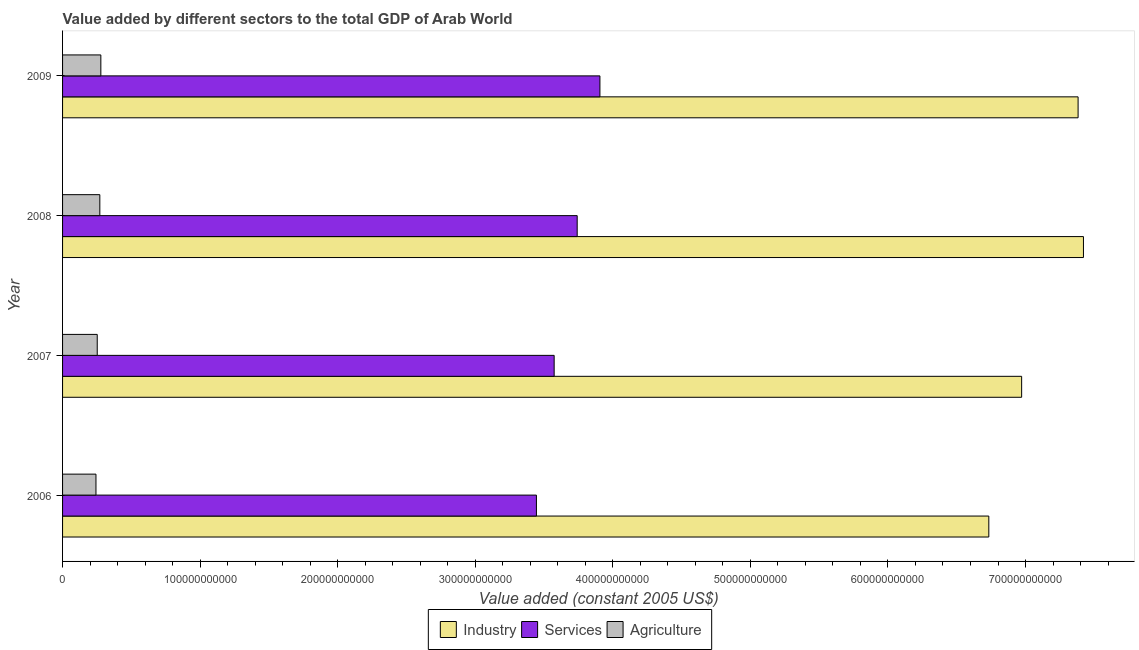Are the number of bars per tick equal to the number of legend labels?
Offer a very short reply. Yes. Are the number of bars on each tick of the Y-axis equal?
Give a very brief answer. Yes. How many bars are there on the 3rd tick from the top?
Provide a succinct answer. 3. In how many cases, is the number of bars for a given year not equal to the number of legend labels?
Provide a short and direct response. 0. What is the value added by agricultural sector in 2008?
Your answer should be very brief. 2.71e+1. Across all years, what is the maximum value added by agricultural sector?
Provide a succinct answer. 2.78e+1. Across all years, what is the minimum value added by industrial sector?
Your answer should be compact. 6.73e+11. In which year was the value added by agricultural sector maximum?
Provide a succinct answer. 2009. What is the total value added by industrial sector in the graph?
Provide a succinct answer. 2.85e+12. What is the difference between the value added by agricultural sector in 2006 and that in 2007?
Keep it short and to the point. -9.24e+08. What is the difference between the value added by industrial sector in 2009 and the value added by agricultural sector in 2008?
Make the answer very short. 7.11e+11. What is the average value added by agricultural sector per year?
Offer a very short reply. 2.61e+1. In the year 2006, what is the difference between the value added by industrial sector and value added by agricultural sector?
Offer a very short reply. 6.49e+11. In how many years, is the value added by services greater than 660000000000 US$?
Your answer should be very brief. 0. What is the ratio of the value added by industrial sector in 2006 to that in 2009?
Make the answer very short. 0.91. Is the value added by industrial sector in 2007 less than that in 2008?
Your answer should be compact. Yes. Is the difference between the value added by services in 2008 and 2009 greater than the difference between the value added by industrial sector in 2008 and 2009?
Make the answer very short. No. What is the difference between the highest and the second highest value added by agricultural sector?
Make the answer very short. 7.33e+08. What is the difference between the highest and the lowest value added by industrial sector?
Your answer should be very brief. 6.88e+1. Is the sum of the value added by industrial sector in 2008 and 2009 greater than the maximum value added by agricultural sector across all years?
Keep it short and to the point. Yes. What does the 3rd bar from the top in 2007 represents?
Your answer should be compact. Industry. What does the 2nd bar from the bottom in 2007 represents?
Offer a very short reply. Services. How many bars are there?
Your response must be concise. 12. How many years are there in the graph?
Your answer should be compact. 4. What is the difference between two consecutive major ticks on the X-axis?
Give a very brief answer. 1.00e+11. What is the title of the graph?
Your answer should be compact. Value added by different sectors to the total GDP of Arab World. Does "Textiles and clothing" appear as one of the legend labels in the graph?
Ensure brevity in your answer.  No. What is the label or title of the X-axis?
Provide a succinct answer. Value added (constant 2005 US$). What is the label or title of the Y-axis?
Give a very brief answer. Year. What is the Value added (constant 2005 US$) in Industry in 2006?
Your answer should be very brief. 6.73e+11. What is the Value added (constant 2005 US$) in Services in 2006?
Your answer should be very brief. 3.44e+11. What is the Value added (constant 2005 US$) of Agriculture in 2006?
Provide a succinct answer. 2.43e+1. What is the Value added (constant 2005 US$) in Industry in 2007?
Your answer should be very brief. 6.97e+11. What is the Value added (constant 2005 US$) in Services in 2007?
Your answer should be compact. 3.57e+11. What is the Value added (constant 2005 US$) in Agriculture in 2007?
Offer a terse response. 2.52e+1. What is the Value added (constant 2005 US$) of Industry in 2008?
Your answer should be very brief. 7.42e+11. What is the Value added (constant 2005 US$) in Services in 2008?
Ensure brevity in your answer.  3.74e+11. What is the Value added (constant 2005 US$) of Agriculture in 2008?
Give a very brief answer. 2.71e+1. What is the Value added (constant 2005 US$) of Industry in 2009?
Give a very brief answer. 7.38e+11. What is the Value added (constant 2005 US$) in Services in 2009?
Offer a very short reply. 3.91e+11. What is the Value added (constant 2005 US$) in Agriculture in 2009?
Your answer should be compact. 2.78e+1. Across all years, what is the maximum Value added (constant 2005 US$) of Industry?
Provide a short and direct response. 7.42e+11. Across all years, what is the maximum Value added (constant 2005 US$) of Services?
Offer a terse response. 3.91e+11. Across all years, what is the maximum Value added (constant 2005 US$) in Agriculture?
Your answer should be very brief. 2.78e+1. Across all years, what is the minimum Value added (constant 2005 US$) of Industry?
Keep it short and to the point. 6.73e+11. Across all years, what is the minimum Value added (constant 2005 US$) of Services?
Offer a terse response. 3.44e+11. Across all years, what is the minimum Value added (constant 2005 US$) of Agriculture?
Give a very brief answer. 2.43e+1. What is the total Value added (constant 2005 US$) in Industry in the graph?
Provide a succinct answer. 2.85e+12. What is the total Value added (constant 2005 US$) of Services in the graph?
Provide a succinct answer. 1.47e+12. What is the total Value added (constant 2005 US$) in Agriculture in the graph?
Offer a terse response. 1.04e+11. What is the difference between the Value added (constant 2005 US$) of Industry in 2006 and that in 2007?
Make the answer very short. -2.39e+1. What is the difference between the Value added (constant 2005 US$) in Services in 2006 and that in 2007?
Offer a terse response. -1.29e+1. What is the difference between the Value added (constant 2005 US$) of Agriculture in 2006 and that in 2007?
Provide a succinct answer. -9.24e+08. What is the difference between the Value added (constant 2005 US$) in Industry in 2006 and that in 2008?
Offer a very short reply. -6.88e+1. What is the difference between the Value added (constant 2005 US$) of Services in 2006 and that in 2008?
Give a very brief answer. -2.96e+1. What is the difference between the Value added (constant 2005 US$) of Agriculture in 2006 and that in 2008?
Your answer should be compact. -2.81e+09. What is the difference between the Value added (constant 2005 US$) of Industry in 2006 and that in 2009?
Your answer should be very brief. -6.49e+1. What is the difference between the Value added (constant 2005 US$) of Services in 2006 and that in 2009?
Provide a short and direct response. -4.62e+1. What is the difference between the Value added (constant 2005 US$) in Agriculture in 2006 and that in 2009?
Make the answer very short. -3.54e+09. What is the difference between the Value added (constant 2005 US$) in Industry in 2007 and that in 2008?
Offer a very short reply. -4.49e+1. What is the difference between the Value added (constant 2005 US$) of Services in 2007 and that in 2008?
Give a very brief answer. -1.67e+1. What is the difference between the Value added (constant 2005 US$) of Agriculture in 2007 and that in 2008?
Give a very brief answer. -1.89e+09. What is the difference between the Value added (constant 2005 US$) in Industry in 2007 and that in 2009?
Offer a terse response. -4.10e+1. What is the difference between the Value added (constant 2005 US$) of Services in 2007 and that in 2009?
Offer a terse response. -3.33e+1. What is the difference between the Value added (constant 2005 US$) of Agriculture in 2007 and that in 2009?
Make the answer very short. -2.62e+09. What is the difference between the Value added (constant 2005 US$) in Industry in 2008 and that in 2009?
Your response must be concise. 3.89e+09. What is the difference between the Value added (constant 2005 US$) of Services in 2008 and that in 2009?
Your response must be concise. -1.65e+1. What is the difference between the Value added (constant 2005 US$) of Agriculture in 2008 and that in 2009?
Your answer should be compact. -7.33e+08. What is the difference between the Value added (constant 2005 US$) of Industry in 2006 and the Value added (constant 2005 US$) of Services in 2007?
Ensure brevity in your answer.  3.16e+11. What is the difference between the Value added (constant 2005 US$) of Industry in 2006 and the Value added (constant 2005 US$) of Agriculture in 2007?
Offer a terse response. 6.48e+11. What is the difference between the Value added (constant 2005 US$) in Services in 2006 and the Value added (constant 2005 US$) in Agriculture in 2007?
Offer a terse response. 3.19e+11. What is the difference between the Value added (constant 2005 US$) in Industry in 2006 and the Value added (constant 2005 US$) in Services in 2008?
Your answer should be compact. 2.99e+11. What is the difference between the Value added (constant 2005 US$) of Industry in 2006 and the Value added (constant 2005 US$) of Agriculture in 2008?
Offer a very short reply. 6.46e+11. What is the difference between the Value added (constant 2005 US$) of Services in 2006 and the Value added (constant 2005 US$) of Agriculture in 2008?
Your response must be concise. 3.17e+11. What is the difference between the Value added (constant 2005 US$) in Industry in 2006 and the Value added (constant 2005 US$) in Services in 2009?
Your response must be concise. 2.83e+11. What is the difference between the Value added (constant 2005 US$) in Industry in 2006 and the Value added (constant 2005 US$) in Agriculture in 2009?
Provide a short and direct response. 6.45e+11. What is the difference between the Value added (constant 2005 US$) in Services in 2006 and the Value added (constant 2005 US$) in Agriculture in 2009?
Your answer should be compact. 3.17e+11. What is the difference between the Value added (constant 2005 US$) of Industry in 2007 and the Value added (constant 2005 US$) of Services in 2008?
Give a very brief answer. 3.23e+11. What is the difference between the Value added (constant 2005 US$) in Industry in 2007 and the Value added (constant 2005 US$) in Agriculture in 2008?
Your response must be concise. 6.70e+11. What is the difference between the Value added (constant 2005 US$) of Services in 2007 and the Value added (constant 2005 US$) of Agriculture in 2008?
Your response must be concise. 3.30e+11. What is the difference between the Value added (constant 2005 US$) of Industry in 2007 and the Value added (constant 2005 US$) of Services in 2009?
Provide a short and direct response. 3.07e+11. What is the difference between the Value added (constant 2005 US$) in Industry in 2007 and the Value added (constant 2005 US$) in Agriculture in 2009?
Offer a very short reply. 6.69e+11. What is the difference between the Value added (constant 2005 US$) of Services in 2007 and the Value added (constant 2005 US$) of Agriculture in 2009?
Make the answer very short. 3.30e+11. What is the difference between the Value added (constant 2005 US$) in Industry in 2008 and the Value added (constant 2005 US$) in Services in 2009?
Offer a terse response. 3.51e+11. What is the difference between the Value added (constant 2005 US$) in Industry in 2008 and the Value added (constant 2005 US$) in Agriculture in 2009?
Give a very brief answer. 7.14e+11. What is the difference between the Value added (constant 2005 US$) of Services in 2008 and the Value added (constant 2005 US$) of Agriculture in 2009?
Your response must be concise. 3.46e+11. What is the average Value added (constant 2005 US$) of Industry per year?
Provide a succinct answer. 7.13e+11. What is the average Value added (constant 2005 US$) in Services per year?
Offer a very short reply. 3.67e+11. What is the average Value added (constant 2005 US$) in Agriculture per year?
Your response must be concise. 2.61e+1. In the year 2006, what is the difference between the Value added (constant 2005 US$) in Industry and Value added (constant 2005 US$) in Services?
Offer a terse response. 3.29e+11. In the year 2006, what is the difference between the Value added (constant 2005 US$) of Industry and Value added (constant 2005 US$) of Agriculture?
Provide a succinct answer. 6.49e+11. In the year 2006, what is the difference between the Value added (constant 2005 US$) of Services and Value added (constant 2005 US$) of Agriculture?
Make the answer very short. 3.20e+11. In the year 2007, what is the difference between the Value added (constant 2005 US$) of Industry and Value added (constant 2005 US$) of Services?
Your answer should be very brief. 3.40e+11. In the year 2007, what is the difference between the Value added (constant 2005 US$) in Industry and Value added (constant 2005 US$) in Agriculture?
Your answer should be very brief. 6.72e+11. In the year 2007, what is the difference between the Value added (constant 2005 US$) of Services and Value added (constant 2005 US$) of Agriculture?
Offer a terse response. 3.32e+11. In the year 2008, what is the difference between the Value added (constant 2005 US$) of Industry and Value added (constant 2005 US$) of Services?
Provide a short and direct response. 3.68e+11. In the year 2008, what is the difference between the Value added (constant 2005 US$) in Industry and Value added (constant 2005 US$) in Agriculture?
Your answer should be compact. 7.15e+11. In the year 2008, what is the difference between the Value added (constant 2005 US$) in Services and Value added (constant 2005 US$) in Agriculture?
Offer a very short reply. 3.47e+11. In the year 2009, what is the difference between the Value added (constant 2005 US$) of Industry and Value added (constant 2005 US$) of Services?
Offer a terse response. 3.48e+11. In the year 2009, what is the difference between the Value added (constant 2005 US$) of Industry and Value added (constant 2005 US$) of Agriculture?
Make the answer very short. 7.10e+11. In the year 2009, what is the difference between the Value added (constant 2005 US$) of Services and Value added (constant 2005 US$) of Agriculture?
Provide a succinct answer. 3.63e+11. What is the ratio of the Value added (constant 2005 US$) in Industry in 2006 to that in 2007?
Your response must be concise. 0.97. What is the ratio of the Value added (constant 2005 US$) of Services in 2006 to that in 2007?
Give a very brief answer. 0.96. What is the ratio of the Value added (constant 2005 US$) in Agriculture in 2006 to that in 2007?
Your answer should be very brief. 0.96. What is the ratio of the Value added (constant 2005 US$) in Industry in 2006 to that in 2008?
Your answer should be very brief. 0.91. What is the ratio of the Value added (constant 2005 US$) of Services in 2006 to that in 2008?
Your answer should be compact. 0.92. What is the ratio of the Value added (constant 2005 US$) of Agriculture in 2006 to that in 2008?
Offer a terse response. 0.9. What is the ratio of the Value added (constant 2005 US$) of Industry in 2006 to that in 2009?
Ensure brevity in your answer.  0.91. What is the ratio of the Value added (constant 2005 US$) of Services in 2006 to that in 2009?
Keep it short and to the point. 0.88. What is the ratio of the Value added (constant 2005 US$) in Agriculture in 2006 to that in 2009?
Give a very brief answer. 0.87. What is the ratio of the Value added (constant 2005 US$) in Industry in 2007 to that in 2008?
Provide a short and direct response. 0.94. What is the ratio of the Value added (constant 2005 US$) in Services in 2007 to that in 2008?
Provide a succinct answer. 0.96. What is the ratio of the Value added (constant 2005 US$) in Agriculture in 2007 to that in 2008?
Provide a succinct answer. 0.93. What is the ratio of the Value added (constant 2005 US$) in Services in 2007 to that in 2009?
Keep it short and to the point. 0.91. What is the ratio of the Value added (constant 2005 US$) in Agriculture in 2007 to that in 2009?
Your answer should be very brief. 0.91. What is the ratio of the Value added (constant 2005 US$) in Industry in 2008 to that in 2009?
Your answer should be very brief. 1.01. What is the ratio of the Value added (constant 2005 US$) in Services in 2008 to that in 2009?
Give a very brief answer. 0.96. What is the ratio of the Value added (constant 2005 US$) of Agriculture in 2008 to that in 2009?
Keep it short and to the point. 0.97. What is the difference between the highest and the second highest Value added (constant 2005 US$) of Industry?
Your response must be concise. 3.89e+09. What is the difference between the highest and the second highest Value added (constant 2005 US$) of Services?
Your answer should be compact. 1.65e+1. What is the difference between the highest and the second highest Value added (constant 2005 US$) in Agriculture?
Offer a terse response. 7.33e+08. What is the difference between the highest and the lowest Value added (constant 2005 US$) in Industry?
Provide a succinct answer. 6.88e+1. What is the difference between the highest and the lowest Value added (constant 2005 US$) in Services?
Keep it short and to the point. 4.62e+1. What is the difference between the highest and the lowest Value added (constant 2005 US$) in Agriculture?
Your answer should be very brief. 3.54e+09. 